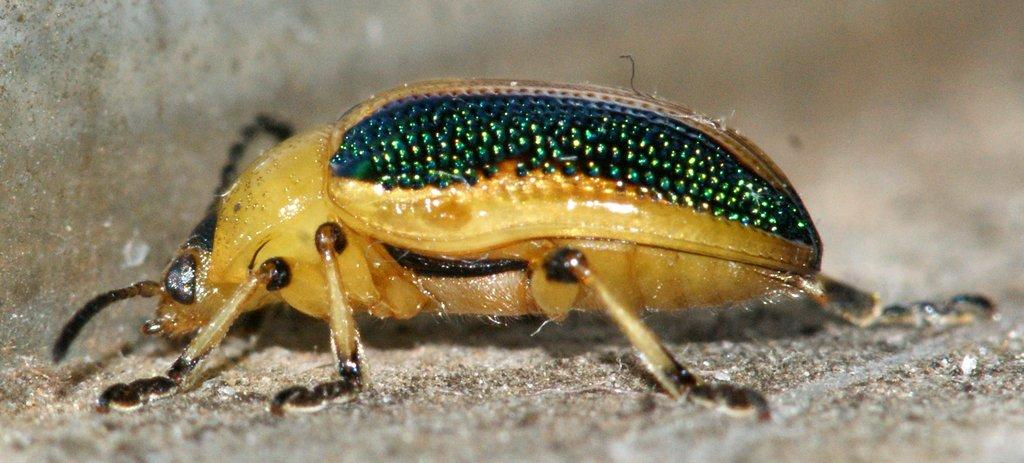What type of creature is present in the image? There is an insect in the image. What is at the bottom of the image? There is a ground at the bottom of the image. What is on the left side of the image? There is a wall on the left side of the image. How would you describe the background of the image? The background of the image is blurred. What type of dress is the sheep wearing in the image? There is no sheep or dress present in the image; it features an insect and a wall. What season is depicted in the image? The image does not depict a specific season, as there are no seasonal cues present. 